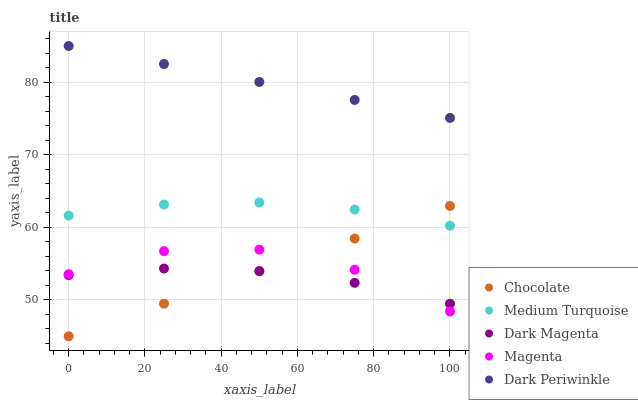Does Dark Magenta have the minimum area under the curve?
Answer yes or no. Yes. Does Dark Periwinkle have the maximum area under the curve?
Answer yes or no. Yes. Does Magenta have the minimum area under the curve?
Answer yes or no. No. Does Magenta have the maximum area under the curve?
Answer yes or no. No. Is Chocolate the smoothest?
Answer yes or no. Yes. Is Magenta the roughest?
Answer yes or no. Yes. Is Dark Magenta the smoothest?
Answer yes or no. No. Is Dark Magenta the roughest?
Answer yes or no. No. Does Chocolate have the lowest value?
Answer yes or no. Yes. Does Magenta have the lowest value?
Answer yes or no. No. Does Dark Periwinkle have the highest value?
Answer yes or no. Yes. Does Magenta have the highest value?
Answer yes or no. No. Is Magenta less than Dark Periwinkle?
Answer yes or no. Yes. Is Medium Turquoise greater than Dark Magenta?
Answer yes or no. Yes. Does Dark Magenta intersect Magenta?
Answer yes or no. Yes. Is Dark Magenta less than Magenta?
Answer yes or no. No. Is Dark Magenta greater than Magenta?
Answer yes or no. No. Does Magenta intersect Dark Periwinkle?
Answer yes or no. No. 